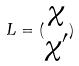Convert formula to latex. <formula><loc_0><loc_0><loc_500><loc_500>L = ( \begin{matrix} \chi \\ \chi ^ { \prime } \end{matrix} )</formula> 